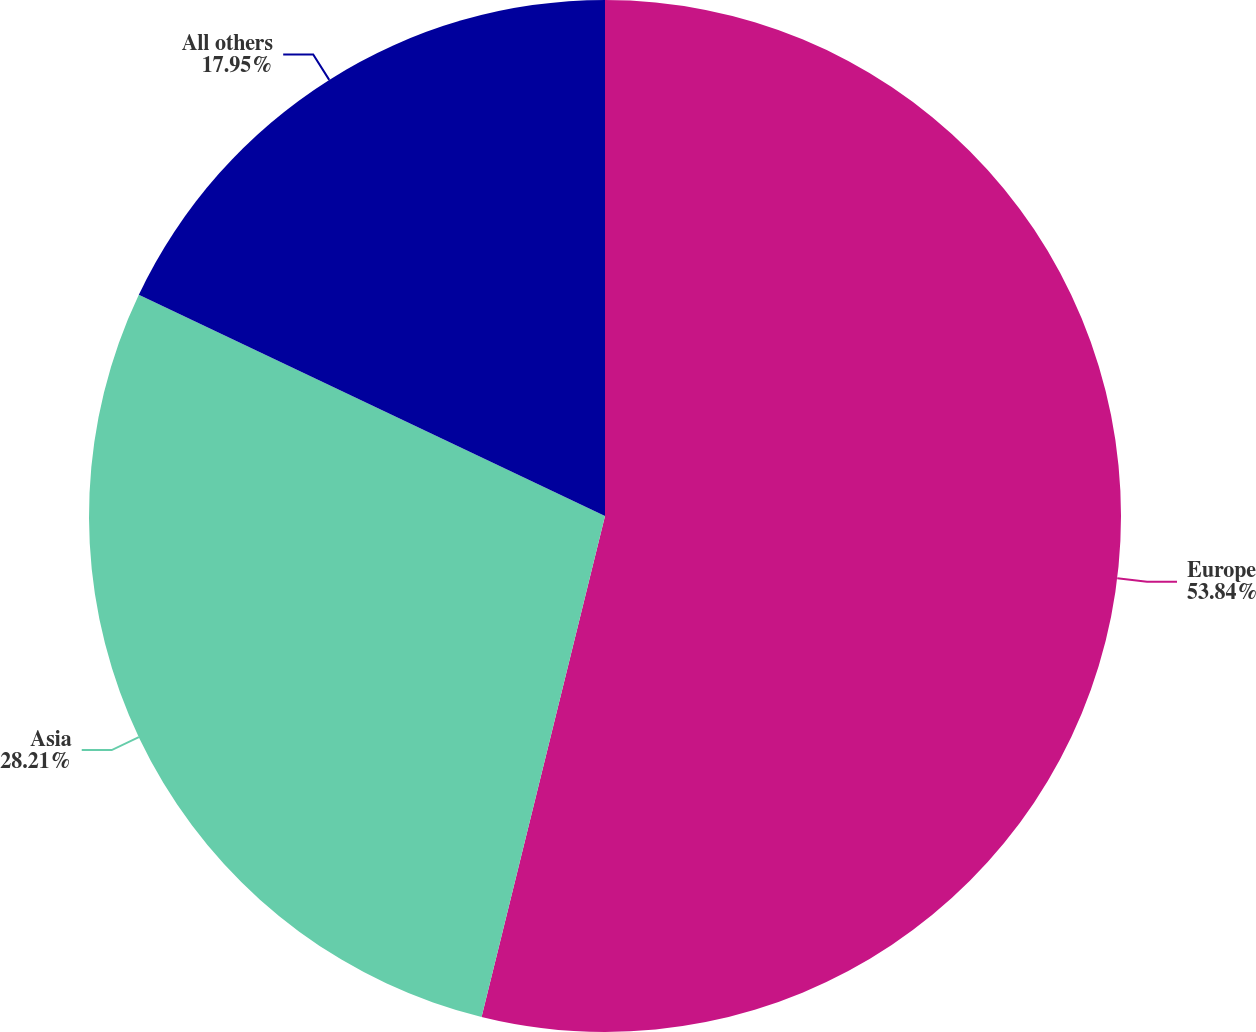Convert chart. <chart><loc_0><loc_0><loc_500><loc_500><pie_chart><fcel>Europe<fcel>Asia<fcel>All others<nl><fcel>53.85%<fcel>28.21%<fcel>17.95%<nl></chart> 